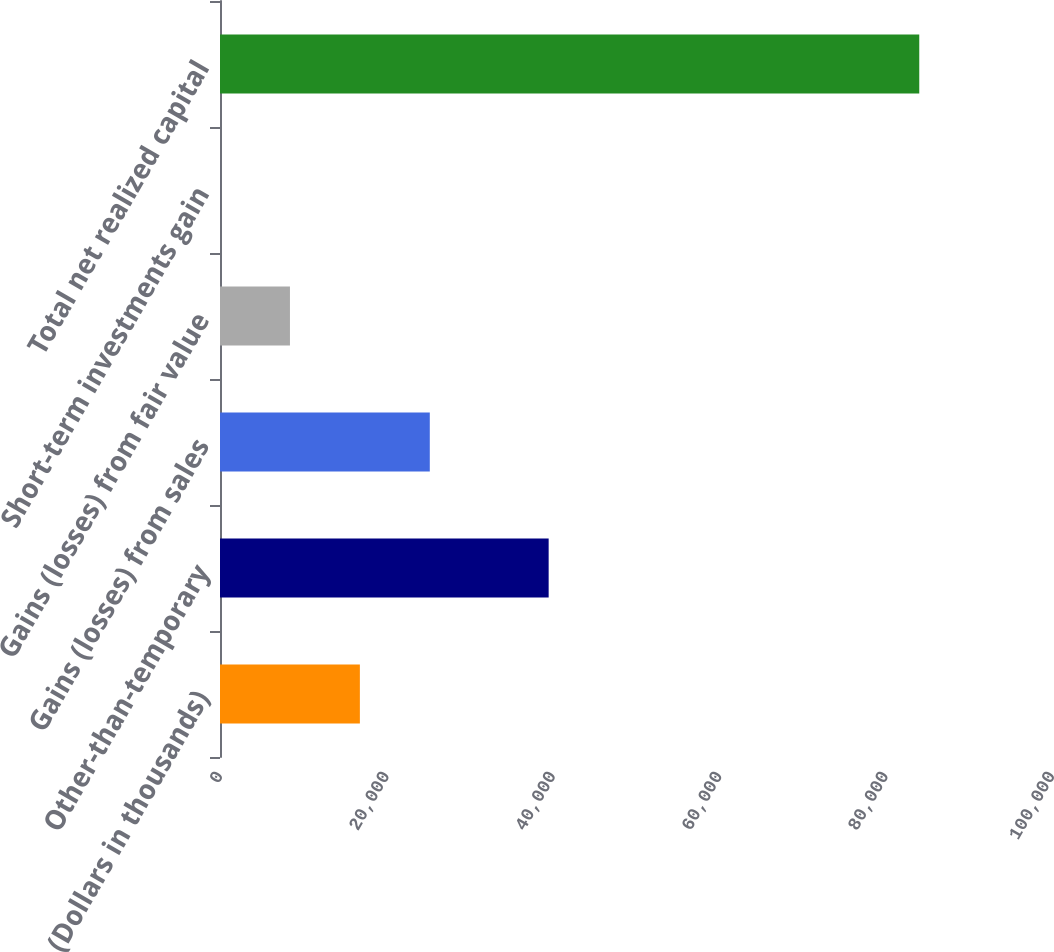Convert chart. <chart><loc_0><loc_0><loc_500><loc_500><bar_chart><fcel>(Dollars in thousands)<fcel>Other-than-temporary<fcel>Gains (losses) from sales<fcel>Gains (losses) from fair value<fcel>Short-term investments gain<fcel>Total net realized capital<nl><fcel>16811.6<fcel>39502<fcel>25215.9<fcel>8407.3<fcel>3<fcel>84046<nl></chart> 